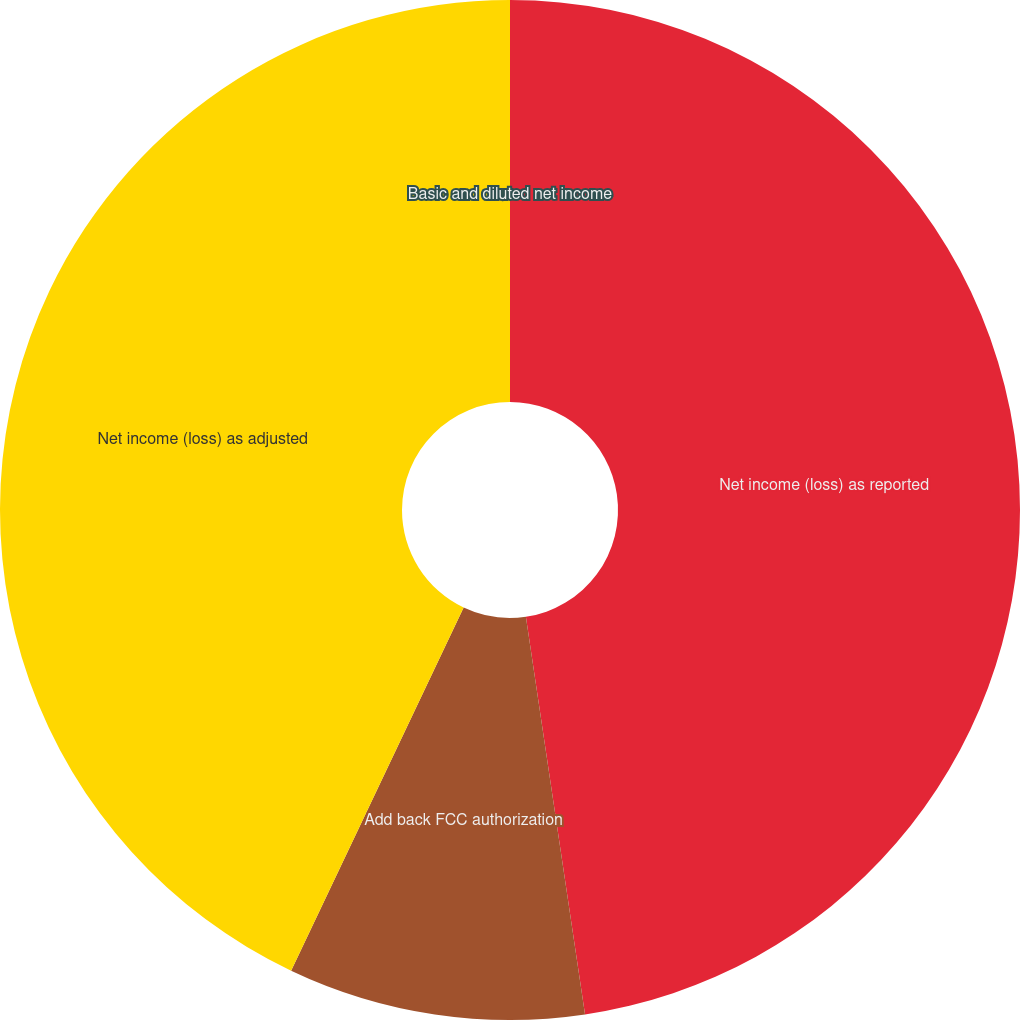Convert chart to OTSL. <chart><loc_0><loc_0><loc_500><loc_500><pie_chart><fcel>Net income (loss) as reported<fcel>Add back FCC authorization<fcel>Net income (loss) as adjusted<fcel>Basic and diluted net income<nl><fcel>47.65%<fcel>9.41%<fcel>42.94%<fcel>0.0%<nl></chart> 